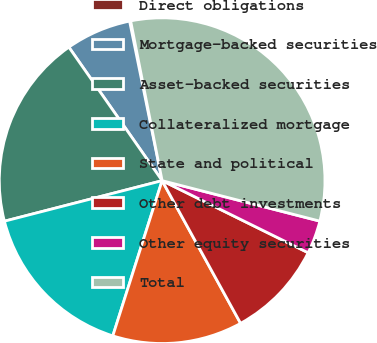Convert chart to OTSL. <chart><loc_0><loc_0><loc_500><loc_500><pie_chart><fcel>Direct obligations<fcel>Mortgage-backed securities<fcel>Asset-backed securities<fcel>Collateralized mortgage<fcel>State and political<fcel>Other debt investments<fcel>Other equity securities<fcel>Total<nl><fcel>0.11%<fcel>6.5%<fcel>19.3%<fcel>16.1%<fcel>12.9%<fcel>9.7%<fcel>3.3%<fcel>32.09%<nl></chart> 